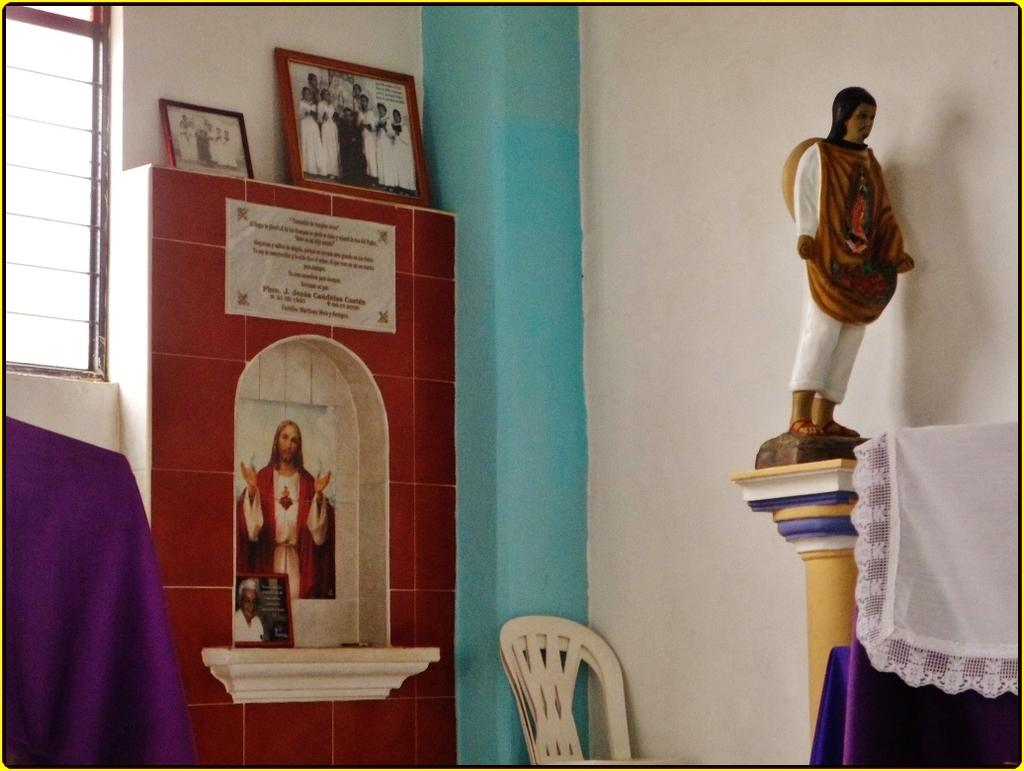What is the main subject in the image? There is a statue in the image. What else can be seen in the image besides the statue? There are cloth-covered objects, chairs, a wall with a picture of a person, photo frames, and a window in the image. What type of objects are covered with cloth? The cloth-covered objects in the image are not specified, but they are likely furniture or decorative items. What is depicted in the picture on the wall? The picture on the wall is of a person. What type of copper material is used to create the pages in the image? There is no copper or pages present in the image. How is the waste being managed in the image? The image does not show any waste or waste management. 